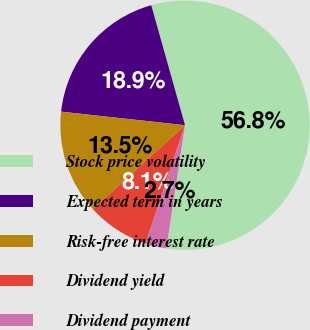Convert chart. <chart><loc_0><loc_0><loc_500><loc_500><pie_chart><fcel>Stock price volatility<fcel>Expected term in years<fcel>Risk-free interest rate<fcel>Dividend yield<fcel>Dividend payment<nl><fcel>56.75%<fcel>18.9%<fcel>13.51%<fcel>8.11%<fcel>2.72%<nl></chart> 